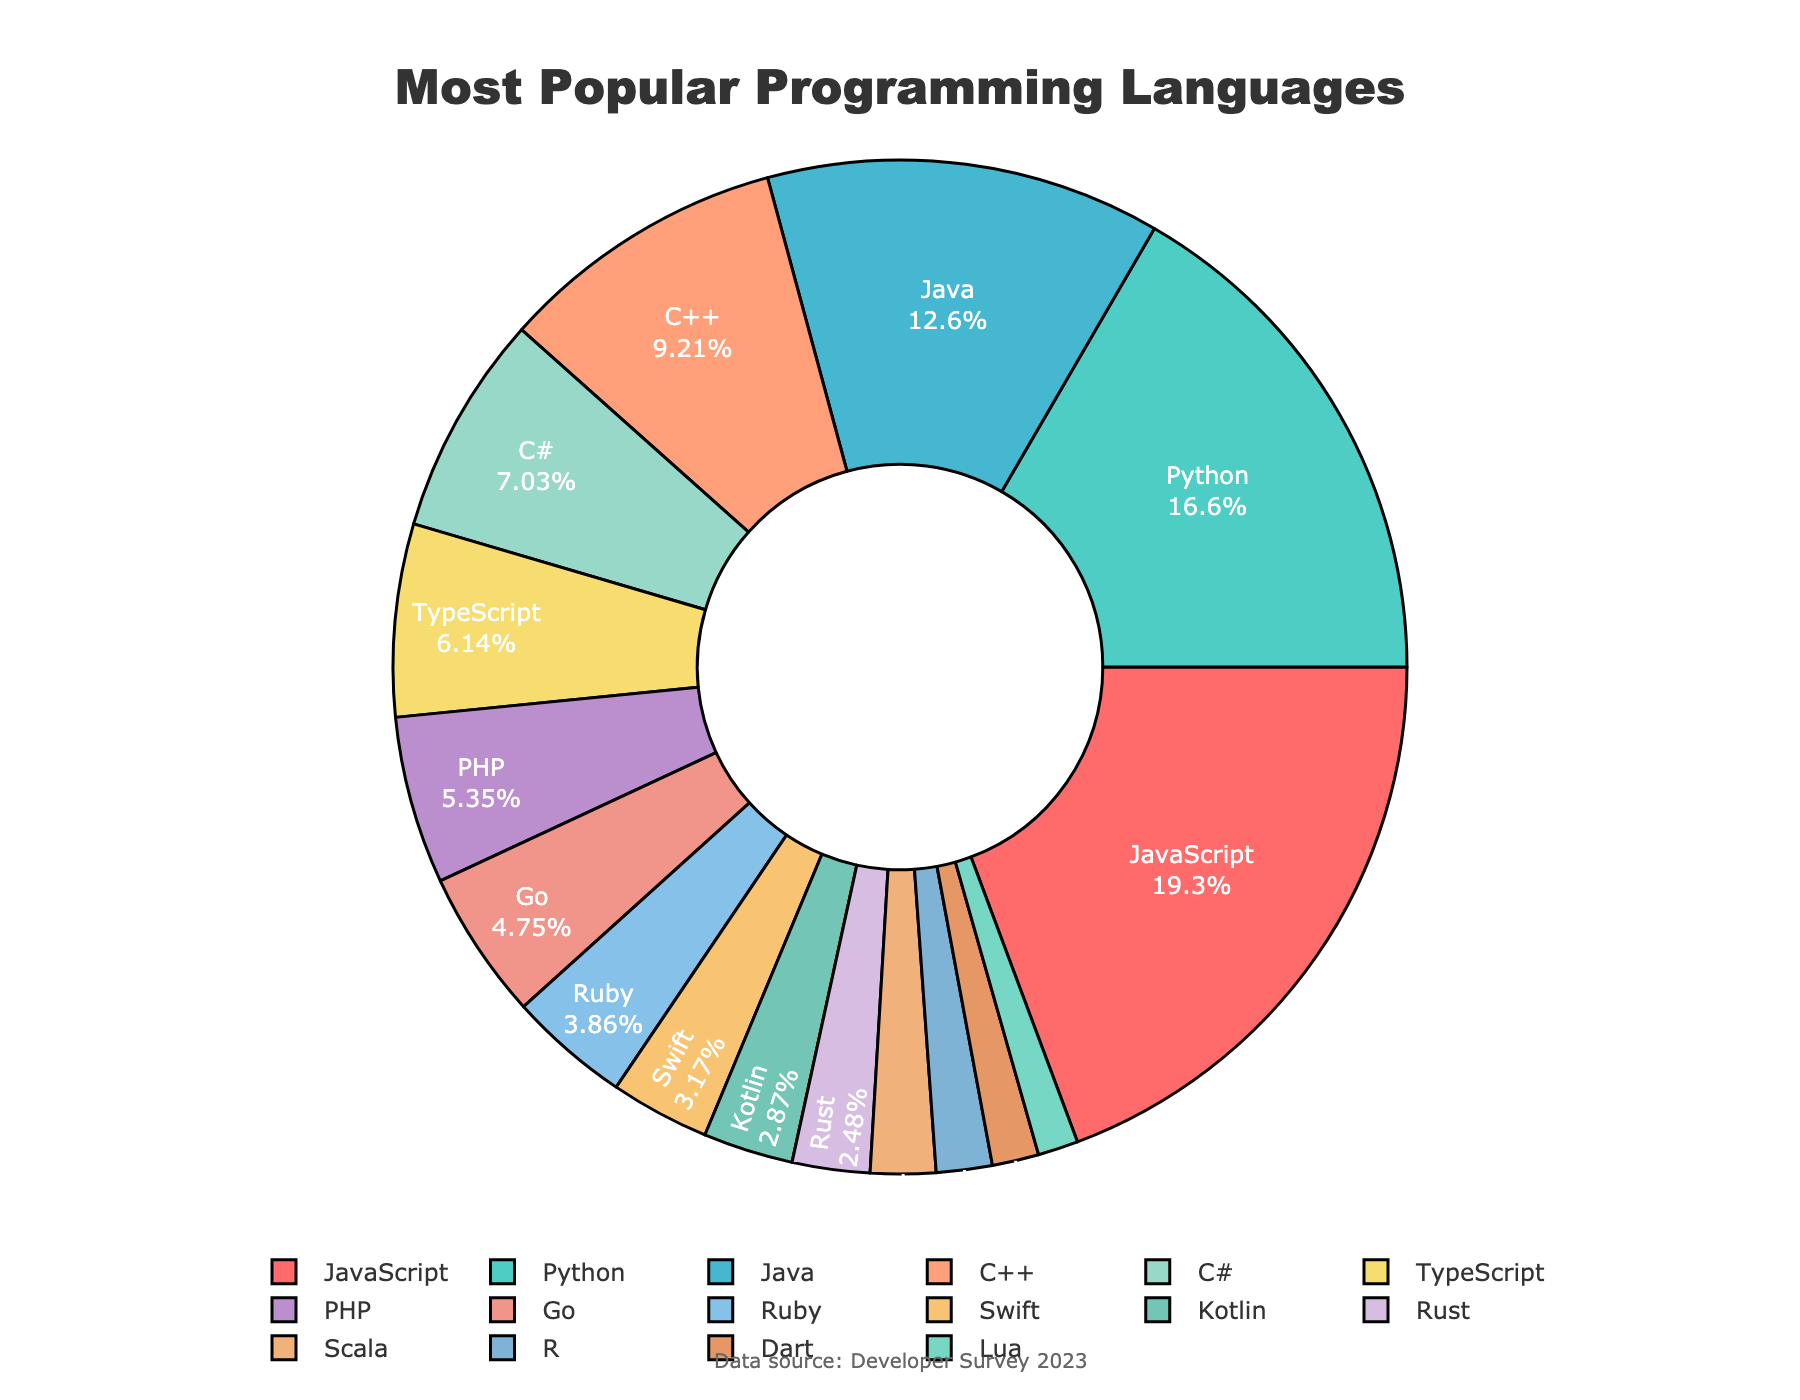What's the most popular programming language according to the figure? The figure shows the breakdown of popular programming languages by percentage, with JavaScript having the largest slice.
Answer: JavaScript What percentage of developers use Python? The figure displays the percentage for each language, and Python is marked with 16.8%.
Answer: 16.8% How much more popular is JavaScript than Java? JavaScript's percentage is 19.5% and Java's is 12.7%. Subtract 12.7 from 19.5 to find the difference. 19.5 - 12.7 = 6.8%
Answer: 6.8% Which language is more popular, C++ or TypeScript, and by how much? The figure shows C++ with 9.3% and TypeScript with 6.2%. Subtract 6.2 from 9.3 to determine the difference. 9.3 - 6.2 = 3.1%
Answer: C++ by 3.1% What is the combined percentage of developers using JavaScript, Python, and Java? Add the percentages of JavaScript (19.5%), Python (16.8%), and Java (12.7%). 19.5 + 16.8 + 12.7 = 49%
Answer: 49% How many languages have a percentage greater than 5%? The languages with percentages above 5% are JavaScript, Python, Java, C++, and C#, TypeScript, and PHP, totaling 7 languages.
Answer: 7 Which programming language has the smallest percentage of users, and what is that percentage? The smallest percentage in the figure is for Lua, with 1.3%.
Answer: Lua with 1.3% Are there more developers using Go or Ruby? According to the figure, Go has 4.8% and Ruby has 3.9%. Therefore, more developers use Go.
Answer: Go What is the percentage difference between the most popular language and the least popular language? JavaScript has the highest percentage at 19.5% and Lua has the lowest at 1.3%. Subtract 1.3 from 19.5 to find the difference. 19.5 - 1.3 = 18.2%
Answer: 18.2% What is the average percentage of the top three languages? The top three languages are JavaScript (19.5%), Python (16.8%), and Java (12.7%). Add these percentages and divide by 3: (19.5 + 16.8 + 12.7) / 3 = 16.33%
Answer: 16.33% 